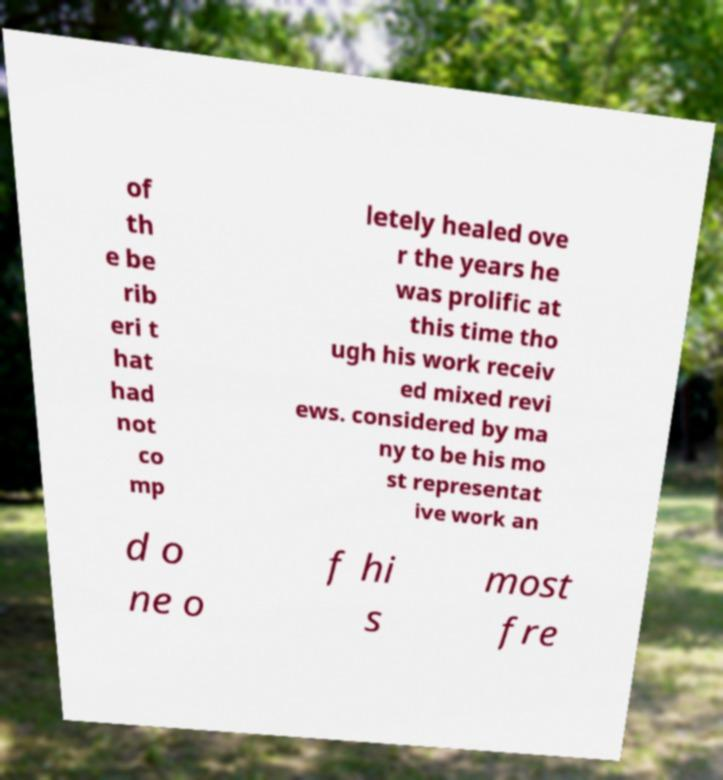Please read and relay the text visible in this image. What does it say? of th e be rib eri t hat had not co mp letely healed ove r the years he was prolific at this time tho ugh his work receiv ed mixed revi ews. considered by ma ny to be his mo st representat ive work an d o ne o f hi s most fre 